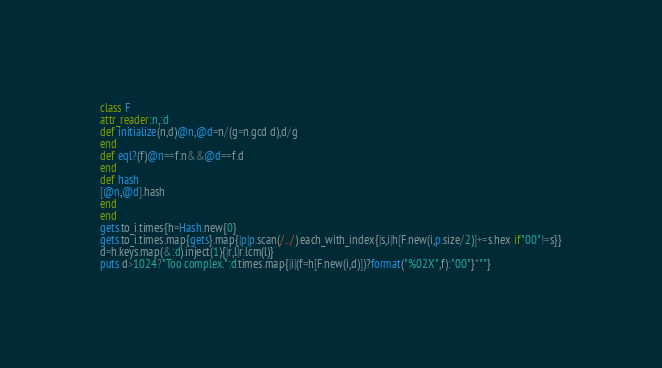<code> <loc_0><loc_0><loc_500><loc_500><_Ruby_>class F
attr_reader:n,:d
def initialize(n,d)@n,@d=n/(g=n.gcd d),d/g
end
def eql?(f)@n==f.n&&@d==f.d
end
def hash
[@n,@d].hash
end
end
gets.to_i.times{h=Hash.new{0}
gets.to_i.times.map{gets}.map{|p|p.scan(/../).each_with_index{|s,i|h[F.new(i,p.size/2)]+=s.hex if"00"!=s}}
d=h.keys.map(&:d).inject(1){|r,l|r.lcm(l)}
puts d>1024?"Too complex.":d.times.map{|i|(f=h[F.new(i,d)])?format("%02X",f):"00"}*""}</code> 